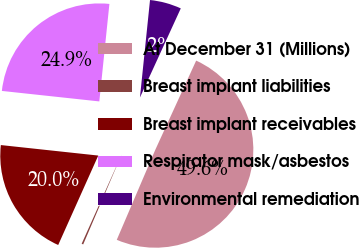<chart> <loc_0><loc_0><loc_500><loc_500><pie_chart><fcel>At December 31 (Millions)<fcel>Breast implant liabilities<fcel>Breast implant receivables<fcel>Respirator mask/asbestos<fcel>Environmental remediation<nl><fcel>49.59%<fcel>0.27%<fcel>20.0%<fcel>24.93%<fcel>5.2%<nl></chart> 